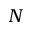Convert formula to latex. <formula><loc_0><loc_0><loc_500><loc_500>N</formula> 